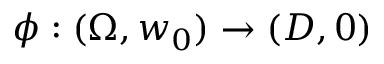<formula> <loc_0><loc_0><loc_500><loc_500>\phi \colon ( \Omega , w _ { 0 } ) \to ( D , 0 )</formula> 